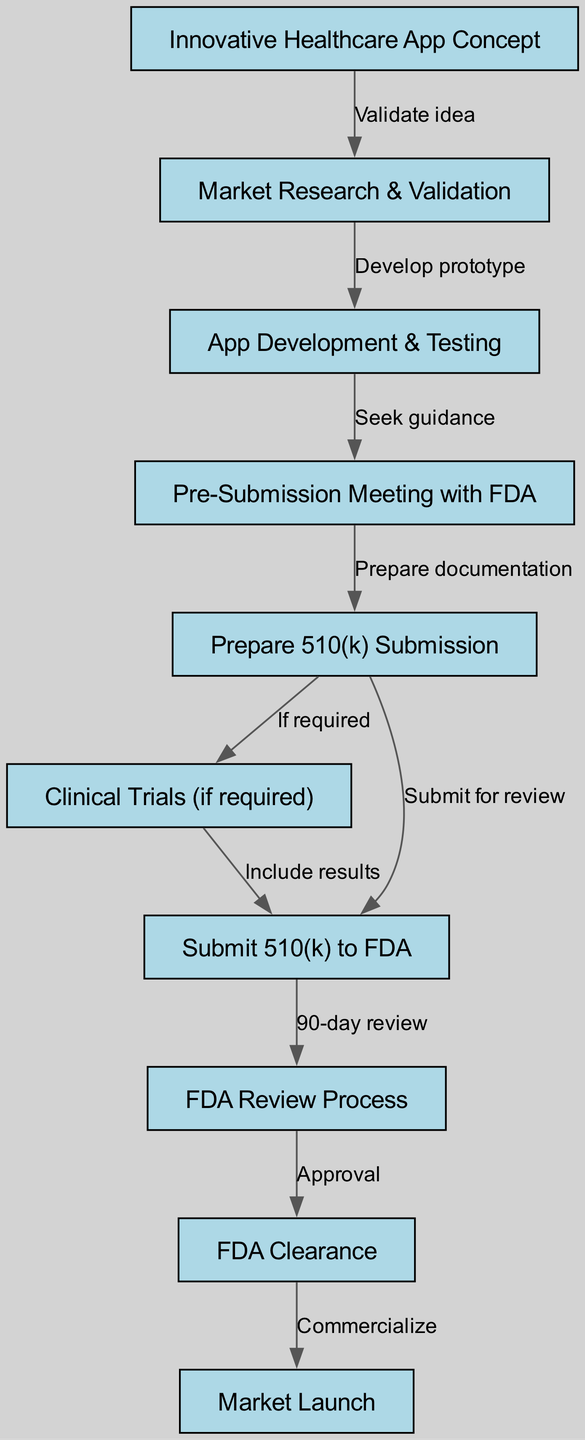What is the first step in the clinical pathway? The first node in the diagram represents the beginning of the pathway, which is labeled "Innovative Healthcare App Concept." This indicates the initial concept that triggers the subsequent steps in the pathway.
Answer: Innovative Healthcare App Concept How many nodes are in the diagram? By counting each listed node in the diagram's data, we find there are ten unique nodes, each representing a different step in the FDA approval process for the healthcare app.
Answer: 10 What connects "Market Research & Validation" to "App Development & Testing"? The edge connecting these two nodes is labeled "Develop prototype," indicating that the validation during market research leads to the development of a prototype of the app.
Answer: Develop prototype Which step follows "FDA Review Process"? Looking at the flow of the diagram, the node that comes immediately after "FDA Review Process" is labeled "FDA Clearance," indicating that clearance is the subsequent step after the review process is completed.
Answer: FDA Clearance What is the relationship between "Prepare 510(k) Submission" and "Submit 510(k) to FDA"? The directed edge between these two nodes shows the action "Submit for review," which indicates that after preparing the documentation for the 510(k) submission, the next step is to submit it to the FDA for their assessment.
Answer: Submit for review In which step is a pre-submission meeting with the FDA held? The node that corresponds to the pre-submission meeting is labeled "Pre-Submission Meeting with FDA," which is the fourth step in the pathway, occurring after the app development and testing has been completed.
Answer: Pre-Submission Meeting with FDA If clinical trials are required, which step follows "Prepare 510(k) Submission"? The diagram connects "Prepare 510(k) Submission" to "Clinical Trials (if required)," indicating that if clinical trials are necessary, they will occur before proceeding to the submission of the 510(k) to the FDA.
Answer: Clinical Trials (if required) What happens after "FDA Clearance"? After receiving FDA clearance, the diagram indicates the next step is "Market Launch," which signifies the commercialization of the app following regulatory approval.
Answer: Market Launch What is included in the submission if clinical trials are conducted? The edge connecting "Clinical Trials (if required)" to "Submit 510(k) to FDA" is labeled "Include results," suggesting that any trial results must be included in the 510(k) submission if they were conducted.
Answer: Include results 